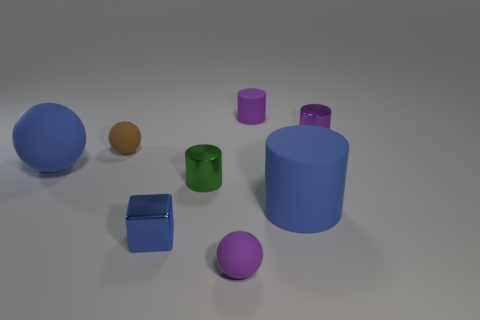Are there more green cylinders behind the tiny purple matte cylinder than green metallic things that are to the left of the brown ball?
Offer a very short reply. No. How many other things are the same size as the blue sphere?
Ensure brevity in your answer.  1. There is a blue thing that is right of the brown rubber ball and behind the small blue thing; what is its material?
Make the answer very short. Rubber. What is the material of the blue object that is the same shape as the green object?
Your response must be concise. Rubber. There is a blue object on the right side of the sphere on the right side of the tiny blue cube; what number of small matte cylinders are to the right of it?
Your response must be concise. 0. Is there anything else of the same color as the big ball?
Keep it short and to the point. Yes. How many spheres are both to the right of the green metallic object and behind the big blue ball?
Give a very brief answer. 0. There is a purple thing that is in front of the tiny brown object; does it have the same size as the purple rubber object behind the blue ball?
Give a very brief answer. Yes. What number of objects are either small balls that are in front of the small blue object or brown metallic spheres?
Give a very brief answer. 1. There is a cylinder in front of the green object; what material is it?
Keep it short and to the point. Rubber. 